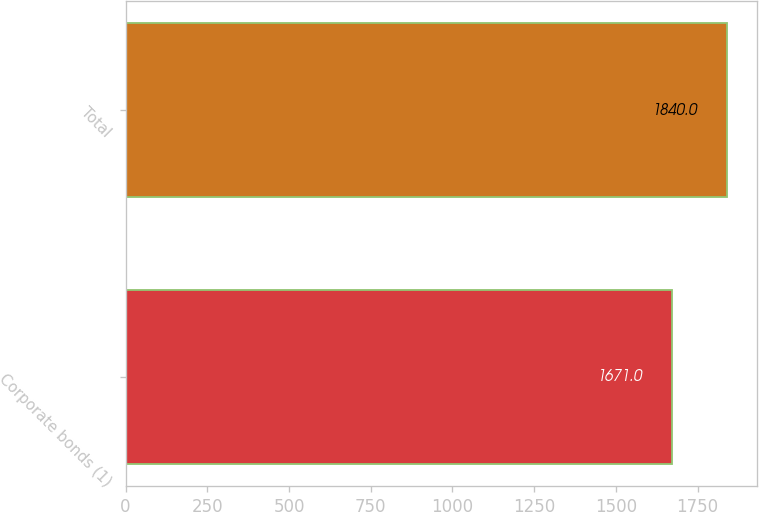Convert chart to OTSL. <chart><loc_0><loc_0><loc_500><loc_500><bar_chart><fcel>Corporate bonds (1)<fcel>Total<nl><fcel>1671<fcel>1840<nl></chart> 